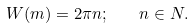<formula> <loc_0><loc_0><loc_500><loc_500>W ( m ) = 2 \pi n ; \quad n \in N .</formula> 